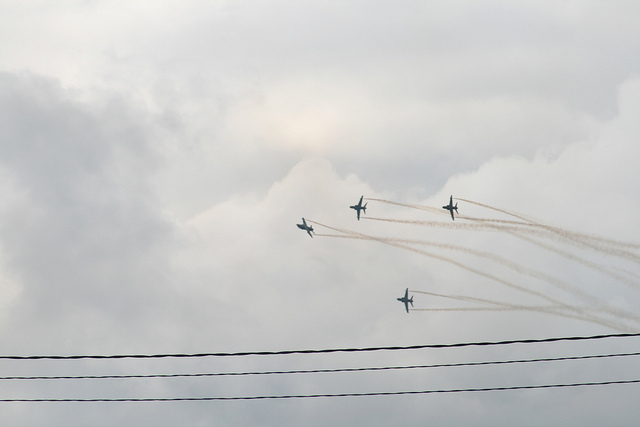<image>What maneuver have the planes just executed? It is unknown what maneuver the planes just executed. It could be a roll, flip, or a flyover. What maneuver have the planes just executed? I don't know what maneuver the planes have just executed. It can be flying upside down, 360, or roll. 